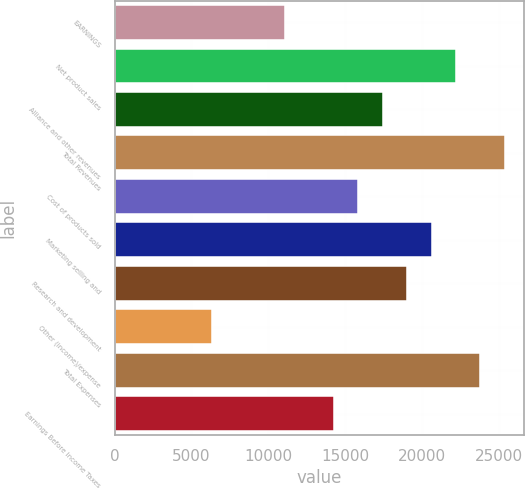Convert chart. <chart><loc_0><loc_0><loc_500><loc_500><bar_chart><fcel>EARNINGS<fcel>Net product sales<fcel>Alliance and other revenues<fcel>Total Revenues<fcel>Cost of products sold<fcel>Marketing selling and<fcel>Research and development<fcel>Other (income)/expense<fcel>Total Expenses<fcel>Earnings Before Income Taxes<nl><fcel>11115.7<fcel>22230.1<fcel>17466.8<fcel>25405.7<fcel>15879<fcel>20642.3<fcel>19054.6<fcel>6352.32<fcel>23817.9<fcel>14291.2<nl></chart> 